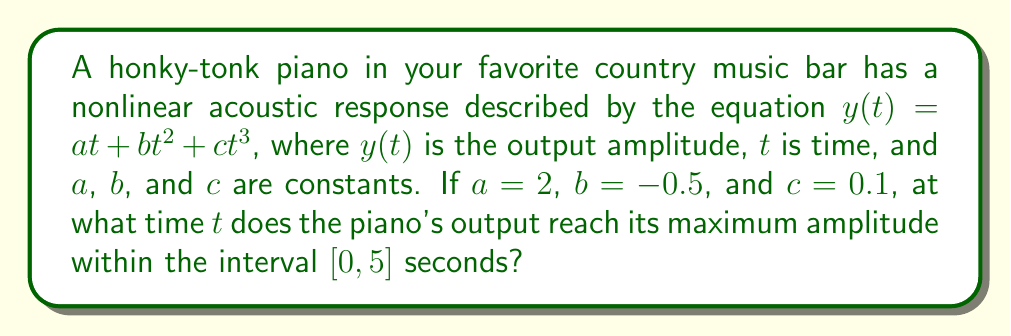Teach me how to tackle this problem. To find the maximum amplitude of the honky-tonk piano's output, we need to follow these steps:

1) The given equation is: $y(t) = at + bt^2 + ct^3$
   With $a = 2$, $b = -0.5$, and $c = 0.1$, we have:
   $y(t) = 2t - 0.5t^2 + 0.1t^3$

2) To find the maximum, we need to find where the derivative $y'(t)$ equals zero:
   $y'(t) = 2 - t + 0.3t^2$

3) Set $y'(t) = 0$:
   $2 - t + 0.3t^2 = 0$

4) This is a quadratic equation. We can solve it using the quadratic formula:
   $t = \frac{-b \pm \sqrt{b^2 - 4ac}}{2a}$

   Where $a = 0.3$, $b = -1$, and $c = 2$

5) Plugging in these values:
   $t = \frac{1 \pm \sqrt{1 - 4(0.3)(2)}}{2(0.3)}$
   $= \frac{1 \pm \sqrt{-1.4}}{0.6}$

6) Since we get imaginary roots, there are no critical points within the real number line.

7) Therefore, the maximum must occur at one of the endpoints of the interval $[0, 5]$.

8) Evaluate $y(t)$ at $t = 0$ and $t = 5$:
   $y(0) = 0$
   $y(5) = 2(5) - 0.5(5^2) + 0.1(5^3) = 10 - 12.5 + 12.5 = 10$

9) The maximum value occurs at $t = 5$ seconds.
Answer: 5 seconds 